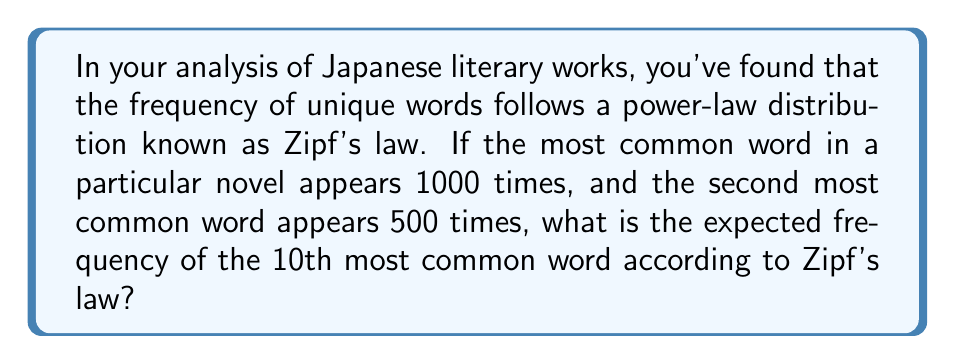What is the answer to this math problem? Let's approach this step-by-step:

1) Zipf's law states that the frequency of a word is inversely proportional to its rank. Mathematically, this can be expressed as:

   $$f(k) = \frac{C}{k^s}$$

   where $f(k)$ is the frequency of the word with rank $k$, $C$ is a constant, and $s$ is close to 1 for natural languages.

2) We can determine the value of $C$ using the information about the most common word:

   $$1000 = \frac{C}{1^s}$$
   $$C = 1000$$

3) Now, let's verify if $s$ is indeed 1 using the information about the second most common word:

   $$500 = \frac{1000}{2^s}$$
   $$2^s = 2$$
   $$s \log 2 = \log 2$$
   $$s = 1$$

4) Now that we have confirmed $s = 1$ and $C = 1000$, we can use Zipf's law to find the frequency of the 10th most common word:

   $$f(10) = \frac{1000}{10^1} = \frac{1000}{10} = 100$$

Therefore, according to Zipf's law, the expected frequency of the 10th most common word in this Japanese novel is 100 times.
Answer: 100 times 